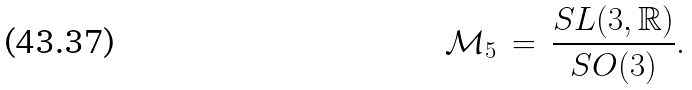Convert formula to latex. <formula><loc_0><loc_0><loc_500><loc_500>\mathcal { M } _ { 5 } \, = \, \frac { S L ( 3 , \mathbb { R } ) } { S O ( 3 ) } .</formula> 